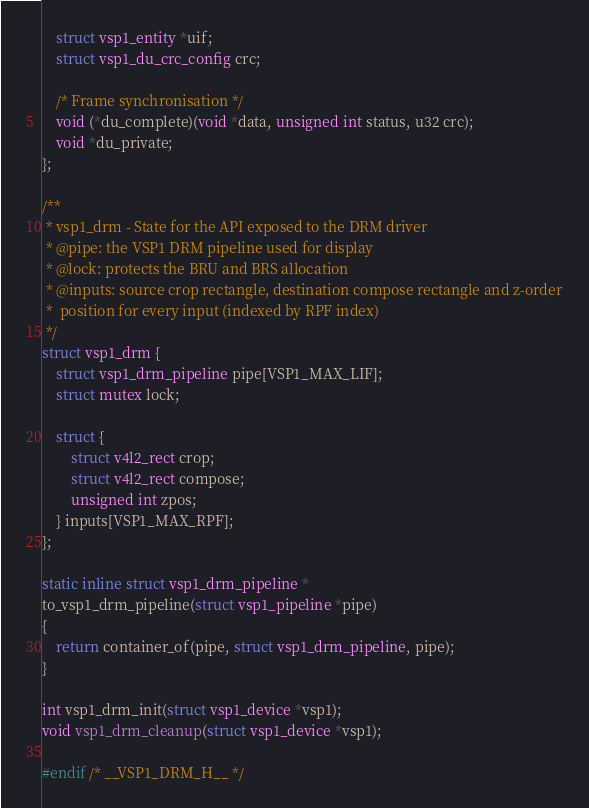Convert code to text. <code><loc_0><loc_0><loc_500><loc_500><_C_>
	struct vsp1_entity *uif;
	struct vsp1_du_crc_config crc;

	/* Frame synchronisation */
	void (*du_complete)(void *data, unsigned int status, u32 crc);
	void *du_private;
};

/**
 * vsp1_drm - State for the API exposed to the DRM driver
 * @pipe: the VSP1 DRM pipeline used for display
 * @lock: protects the BRU and BRS allocation
 * @inputs: source crop rectangle, destination compose rectangle and z-order
 *	position for every input (indexed by RPF index)
 */
struct vsp1_drm {
	struct vsp1_drm_pipeline pipe[VSP1_MAX_LIF];
	struct mutex lock;

	struct {
		struct v4l2_rect crop;
		struct v4l2_rect compose;
		unsigned int zpos;
	} inputs[VSP1_MAX_RPF];
};

static inline struct vsp1_drm_pipeline *
to_vsp1_drm_pipeline(struct vsp1_pipeline *pipe)
{
	return container_of(pipe, struct vsp1_drm_pipeline, pipe);
}

int vsp1_drm_init(struct vsp1_device *vsp1);
void vsp1_drm_cleanup(struct vsp1_device *vsp1);

#endif /* __VSP1_DRM_H__ */
</code> 